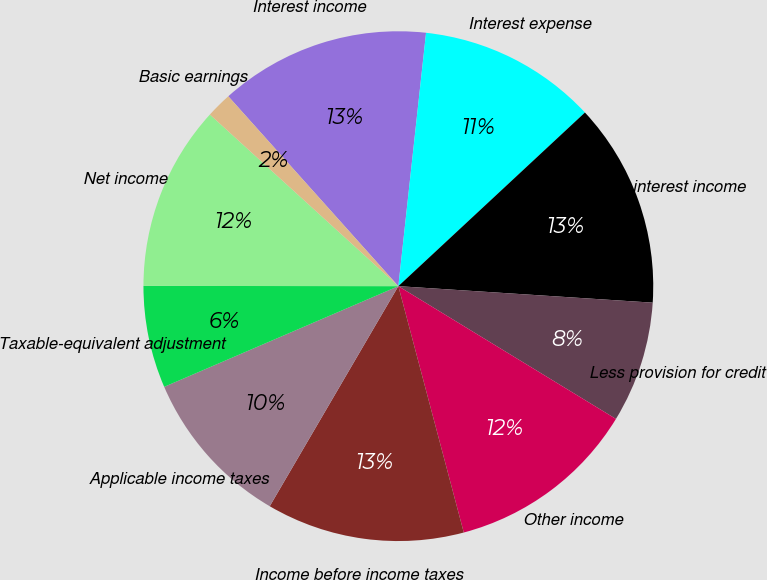<chart> <loc_0><loc_0><loc_500><loc_500><pie_chart><fcel>Interest income<fcel>Interest expense<fcel>Net interest income<fcel>Less provision for credit<fcel>Other income<fcel>Income before income taxes<fcel>Applicable income taxes<fcel>Taxable-equivalent adjustment<fcel>Net income<fcel>Basic earnings<nl><fcel>13.36%<fcel>11.34%<fcel>12.96%<fcel>7.69%<fcel>12.15%<fcel>12.55%<fcel>10.12%<fcel>6.48%<fcel>11.74%<fcel>1.62%<nl></chart> 